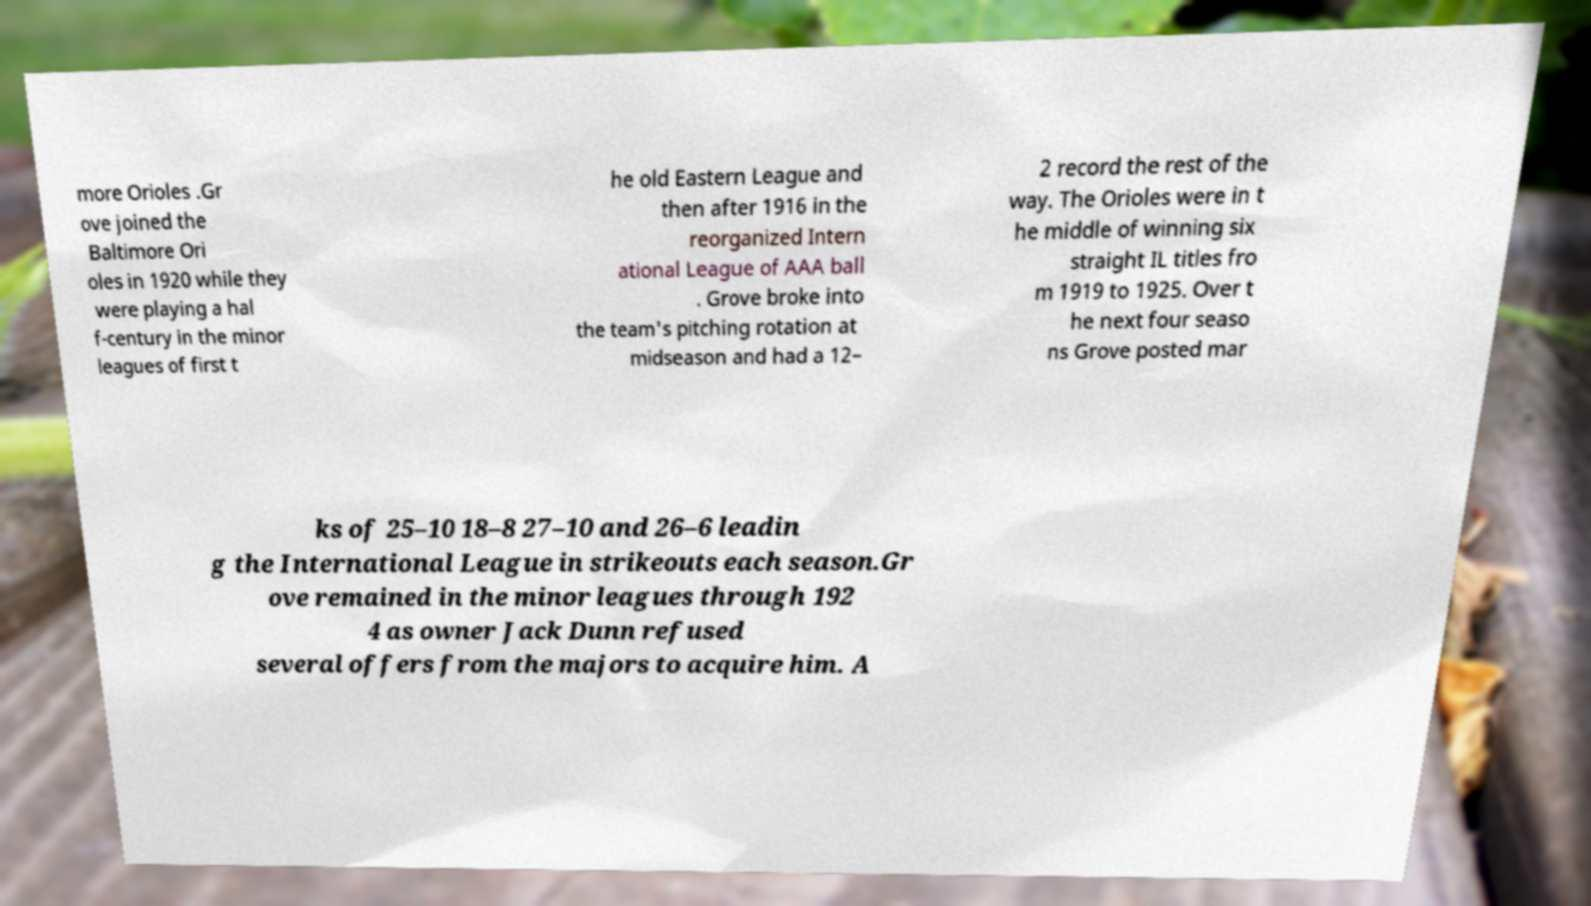Can you accurately transcribe the text from the provided image for me? more Orioles .Gr ove joined the Baltimore Ori oles in 1920 while they were playing a hal f-century in the minor leagues of first t he old Eastern League and then after 1916 in the reorganized Intern ational League of AAA ball . Grove broke into the team's pitching rotation at midseason and had a 12– 2 record the rest of the way. The Orioles were in t he middle of winning six straight IL titles fro m 1919 to 1925. Over t he next four seaso ns Grove posted mar ks of 25–10 18–8 27–10 and 26–6 leadin g the International League in strikeouts each season.Gr ove remained in the minor leagues through 192 4 as owner Jack Dunn refused several offers from the majors to acquire him. A 